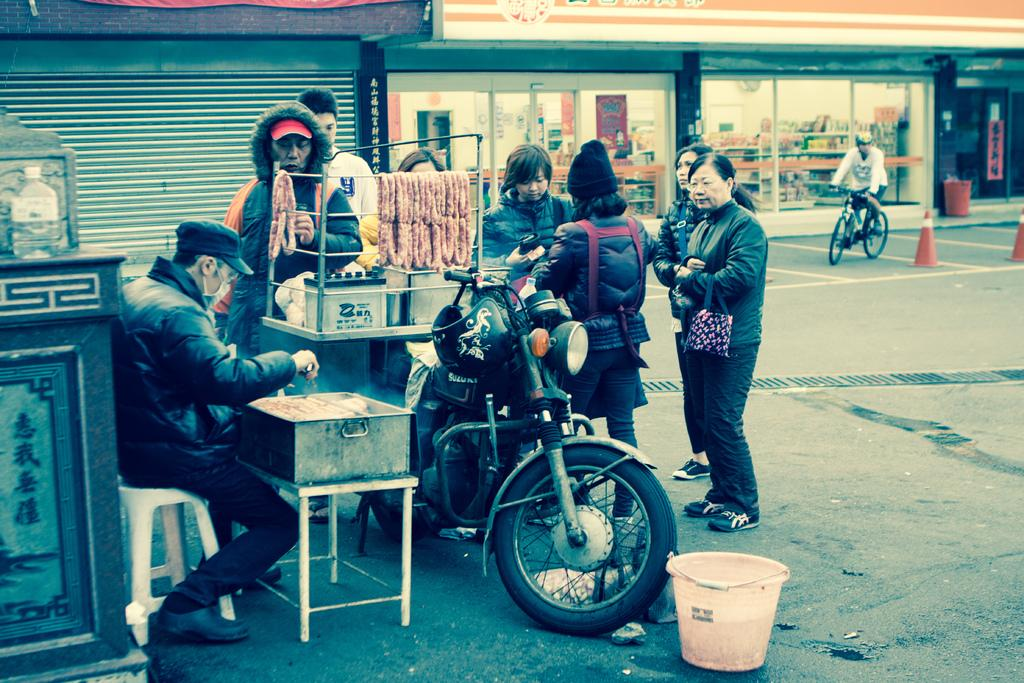What is the man in the image doing? The man is seated and selling food in the image. Are there any other people in the image besides the man selling food? Yes, there are people standing in the image. What type of vehicle can be seen in the image? There is a motorcycle in the image. Is there anyone else in the image besides the man selling food and the people standing? Yes, there is a man riding a bicycle in the image. Can you tell me what the maid is doing in the image? There is no maid present in the image. Is the actor performing a scene in the image? There is no actor or performance depicted in the image. 